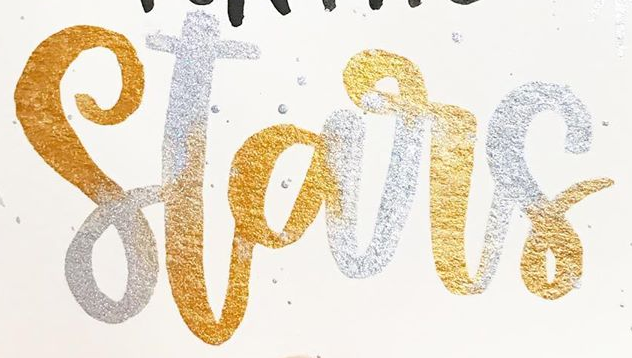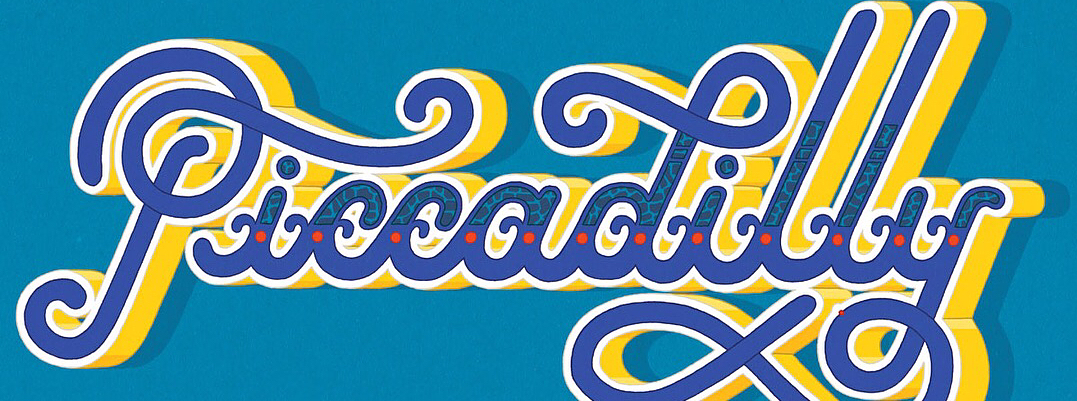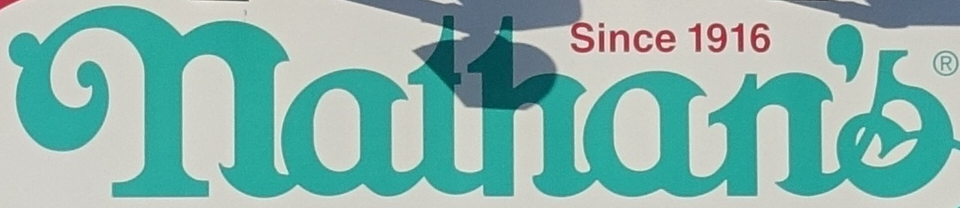Identify the words shown in these images in order, separated by a semicolon. Stars; Piccadilly; nathan's 